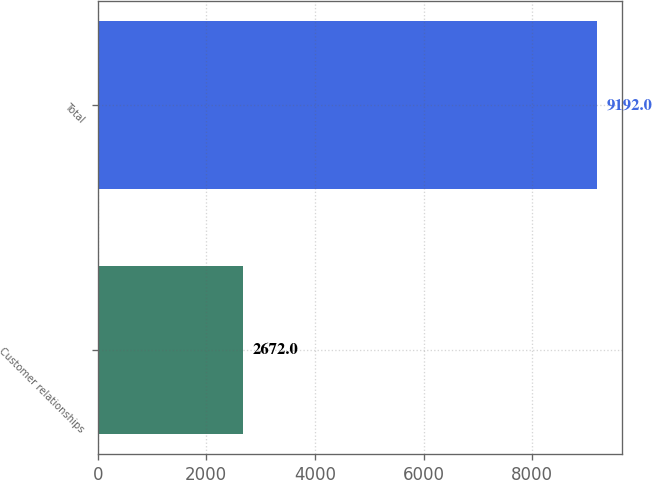<chart> <loc_0><loc_0><loc_500><loc_500><bar_chart><fcel>Customer relationships<fcel>Total<nl><fcel>2672<fcel>9192<nl></chart> 